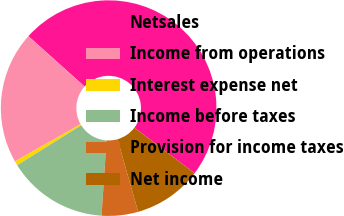<chart> <loc_0><loc_0><loc_500><loc_500><pie_chart><fcel>Netsales<fcel>Income from operations<fcel>Interest expense net<fcel>Income before taxes<fcel>Provision for income taxes<fcel>Net income<nl><fcel>48.69%<fcel>19.87%<fcel>0.65%<fcel>15.07%<fcel>5.46%<fcel>10.26%<nl></chart> 